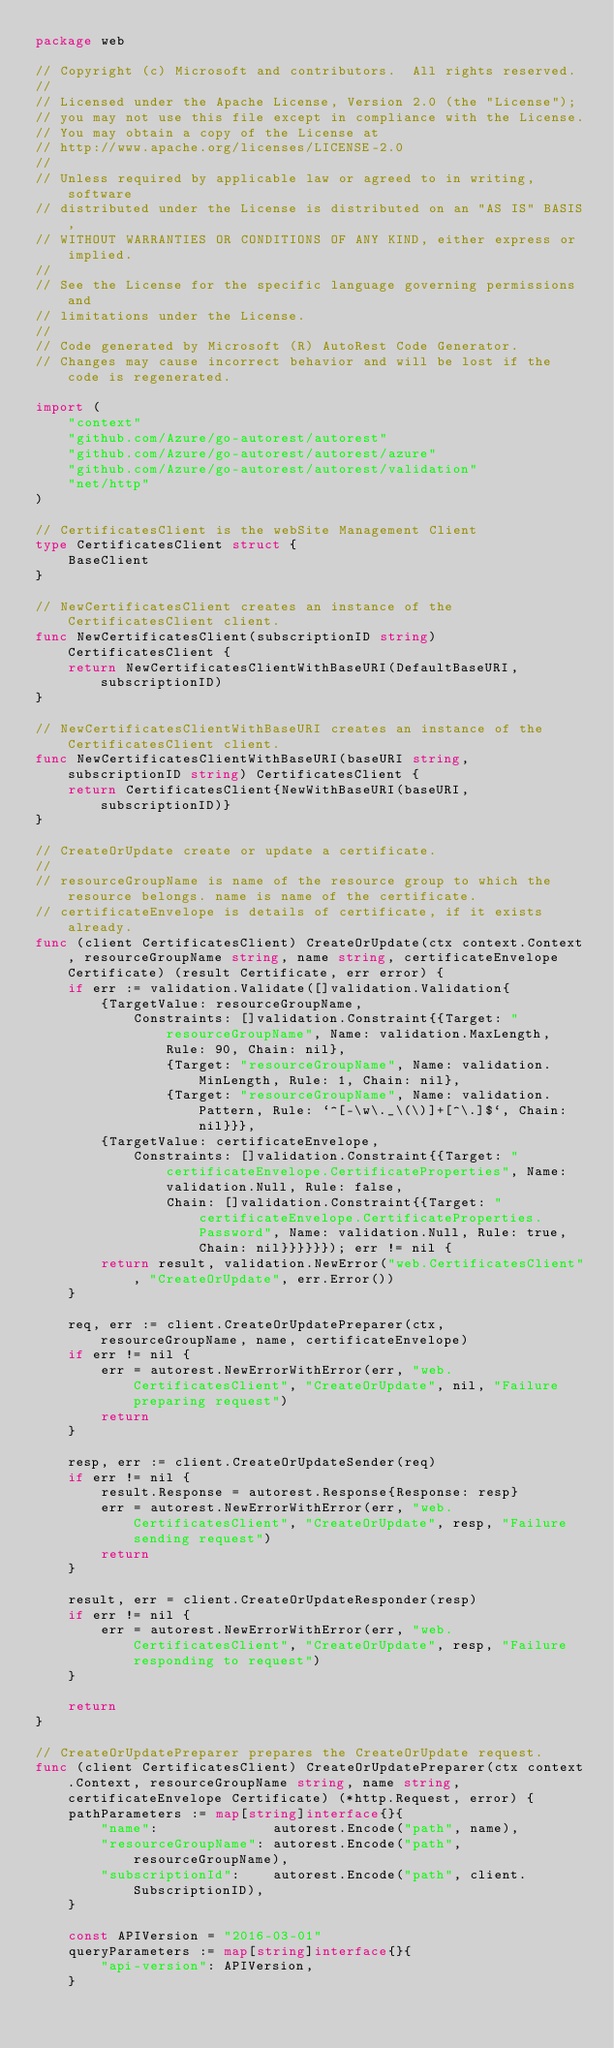Convert code to text. <code><loc_0><loc_0><loc_500><loc_500><_Go_>package web

// Copyright (c) Microsoft and contributors.  All rights reserved.
//
// Licensed under the Apache License, Version 2.0 (the "License");
// you may not use this file except in compliance with the License.
// You may obtain a copy of the License at
// http://www.apache.org/licenses/LICENSE-2.0
//
// Unless required by applicable law or agreed to in writing, software
// distributed under the License is distributed on an "AS IS" BASIS,
// WITHOUT WARRANTIES OR CONDITIONS OF ANY KIND, either express or implied.
//
// See the License for the specific language governing permissions and
// limitations under the License.
//
// Code generated by Microsoft (R) AutoRest Code Generator.
// Changes may cause incorrect behavior and will be lost if the code is regenerated.

import (
	"context"
	"github.com/Azure/go-autorest/autorest"
	"github.com/Azure/go-autorest/autorest/azure"
	"github.com/Azure/go-autorest/autorest/validation"
	"net/http"
)

// CertificatesClient is the webSite Management Client
type CertificatesClient struct {
	BaseClient
}

// NewCertificatesClient creates an instance of the CertificatesClient client.
func NewCertificatesClient(subscriptionID string) CertificatesClient {
	return NewCertificatesClientWithBaseURI(DefaultBaseURI, subscriptionID)
}

// NewCertificatesClientWithBaseURI creates an instance of the CertificatesClient client.
func NewCertificatesClientWithBaseURI(baseURI string, subscriptionID string) CertificatesClient {
	return CertificatesClient{NewWithBaseURI(baseURI, subscriptionID)}
}

// CreateOrUpdate create or update a certificate.
//
// resourceGroupName is name of the resource group to which the resource belongs. name is name of the certificate.
// certificateEnvelope is details of certificate, if it exists already.
func (client CertificatesClient) CreateOrUpdate(ctx context.Context, resourceGroupName string, name string, certificateEnvelope Certificate) (result Certificate, err error) {
	if err := validation.Validate([]validation.Validation{
		{TargetValue: resourceGroupName,
			Constraints: []validation.Constraint{{Target: "resourceGroupName", Name: validation.MaxLength, Rule: 90, Chain: nil},
				{Target: "resourceGroupName", Name: validation.MinLength, Rule: 1, Chain: nil},
				{Target: "resourceGroupName", Name: validation.Pattern, Rule: `^[-\w\._\(\)]+[^\.]$`, Chain: nil}}},
		{TargetValue: certificateEnvelope,
			Constraints: []validation.Constraint{{Target: "certificateEnvelope.CertificateProperties", Name: validation.Null, Rule: false,
				Chain: []validation.Constraint{{Target: "certificateEnvelope.CertificateProperties.Password", Name: validation.Null, Rule: true, Chain: nil}}}}}}); err != nil {
		return result, validation.NewError("web.CertificatesClient", "CreateOrUpdate", err.Error())
	}

	req, err := client.CreateOrUpdatePreparer(ctx, resourceGroupName, name, certificateEnvelope)
	if err != nil {
		err = autorest.NewErrorWithError(err, "web.CertificatesClient", "CreateOrUpdate", nil, "Failure preparing request")
		return
	}

	resp, err := client.CreateOrUpdateSender(req)
	if err != nil {
		result.Response = autorest.Response{Response: resp}
		err = autorest.NewErrorWithError(err, "web.CertificatesClient", "CreateOrUpdate", resp, "Failure sending request")
		return
	}

	result, err = client.CreateOrUpdateResponder(resp)
	if err != nil {
		err = autorest.NewErrorWithError(err, "web.CertificatesClient", "CreateOrUpdate", resp, "Failure responding to request")
	}

	return
}

// CreateOrUpdatePreparer prepares the CreateOrUpdate request.
func (client CertificatesClient) CreateOrUpdatePreparer(ctx context.Context, resourceGroupName string, name string, certificateEnvelope Certificate) (*http.Request, error) {
	pathParameters := map[string]interface{}{
		"name":              autorest.Encode("path", name),
		"resourceGroupName": autorest.Encode("path", resourceGroupName),
		"subscriptionId":    autorest.Encode("path", client.SubscriptionID),
	}

	const APIVersion = "2016-03-01"
	queryParameters := map[string]interface{}{
		"api-version": APIVersion,
	}
</code> 